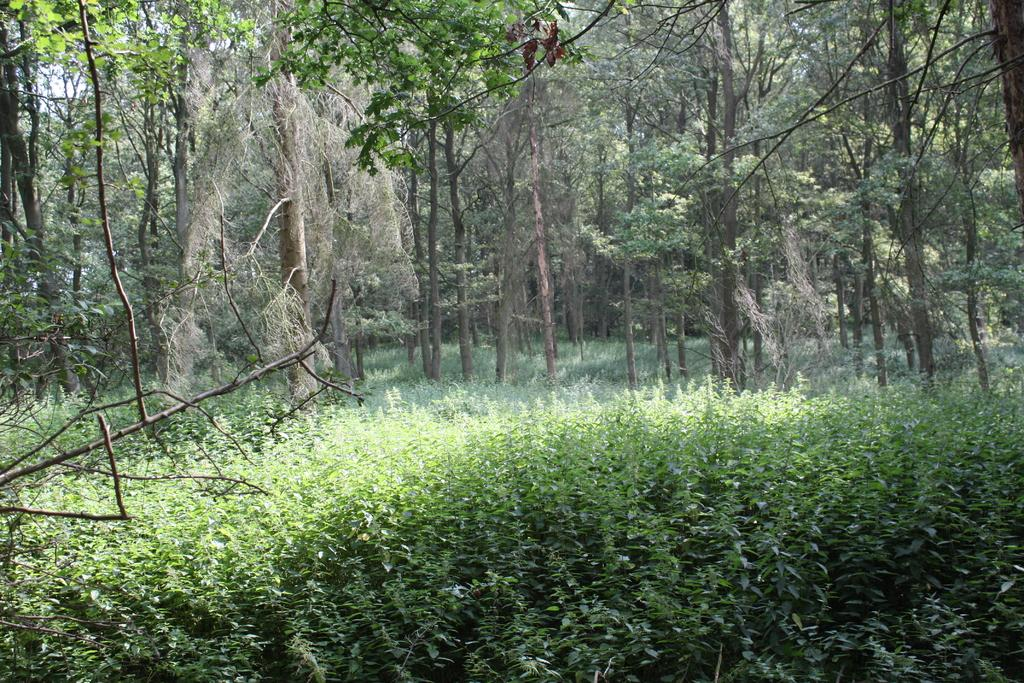What type of vegetation is in the foreground of the image? There are plants in the foreground of the image. What type of vegetation is in the background of the image? There are trees in the background of the image. What else can be seen in the background of the image? The sky is visible in the background of the image. Can you see any veins in the plants in the image? There are no visible veins in the plants in the image, as veins are not visible to the naked eye in plants. 